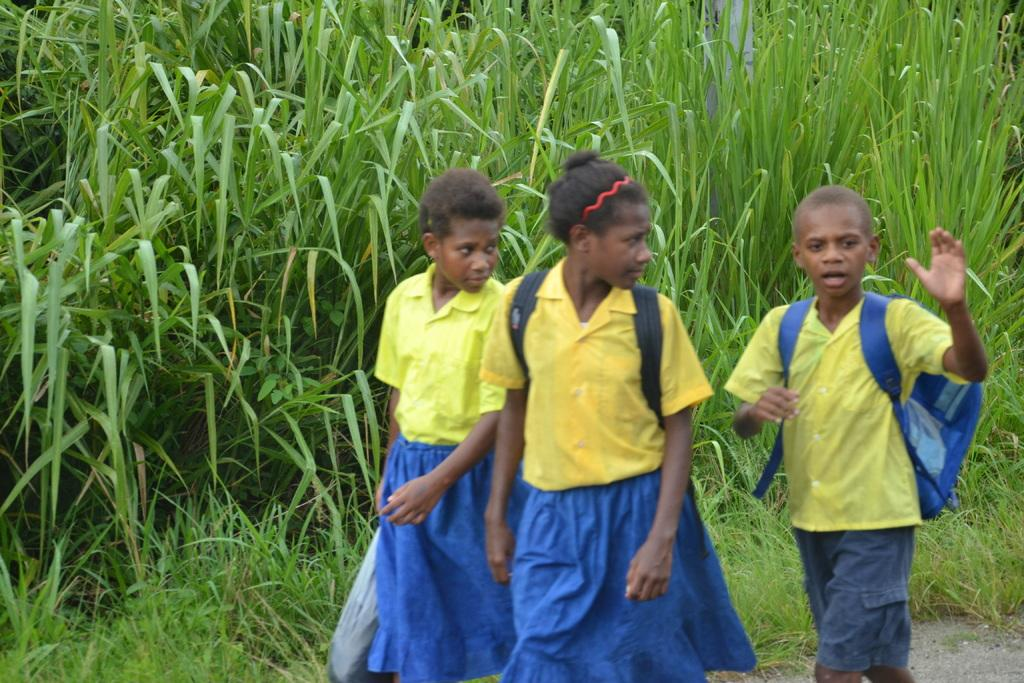How many kids are in the image? There are three kids in the image. What is one of the kids doing in the image? One of the kids is holding an object. What type of vegetation can be seen in the image? There are plants and grass visible in the image. What can be seen in the background of the image? There appears to be a pole in the background of the image. How many women are present in the image? There is no mention of women in the image, so we cannot determine their presence. 